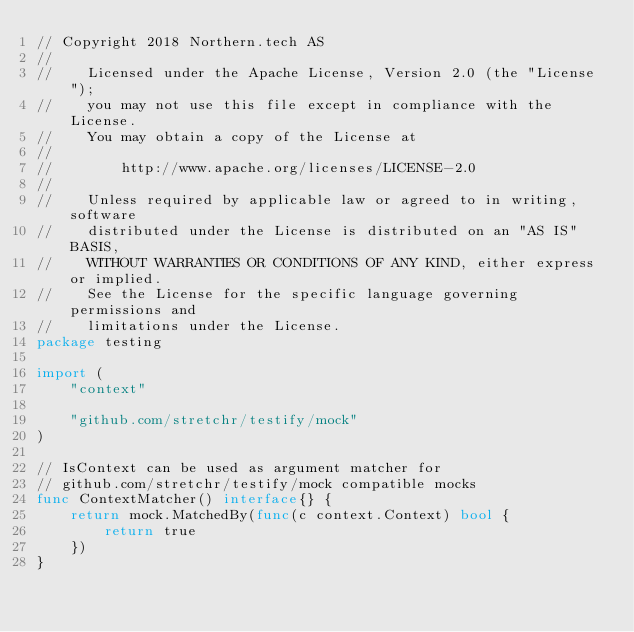<code> <loc_0><loc_0><loc_500><loc_500><_Go_>// Copyright 2018 Northern.tech AS
//
//    Licensed under the Apache License, Version 2.0 (the "License");
//    you may not use this file except in compliance with the License.
//    You may obtain a copy of the License at
//
//        http://www.apache.org/licenses/LICENSE-2.0
//
//    Unless required by applicable law or agreed to in writing, software
//    distributed under the License is distributed on an "AS IS" BASIS,
//    WITHOUT WARRANTIES OR CONDITIONS OF ANY KIND, either express or implied.
//    See the License for the specific language governing permissions and
//    limitations under the License.
package testing

import (
	"context"

	"github.com/stretchr/testify/mock"
)

// IsContext can be used as argument matcher for
// github.com/stretchr/testify/mock compatible mocks
func ContextMatcher() interface{} {
	return mock.MatchedBy(func(c context.Context) bool {
		return true
	})
}
</code> 